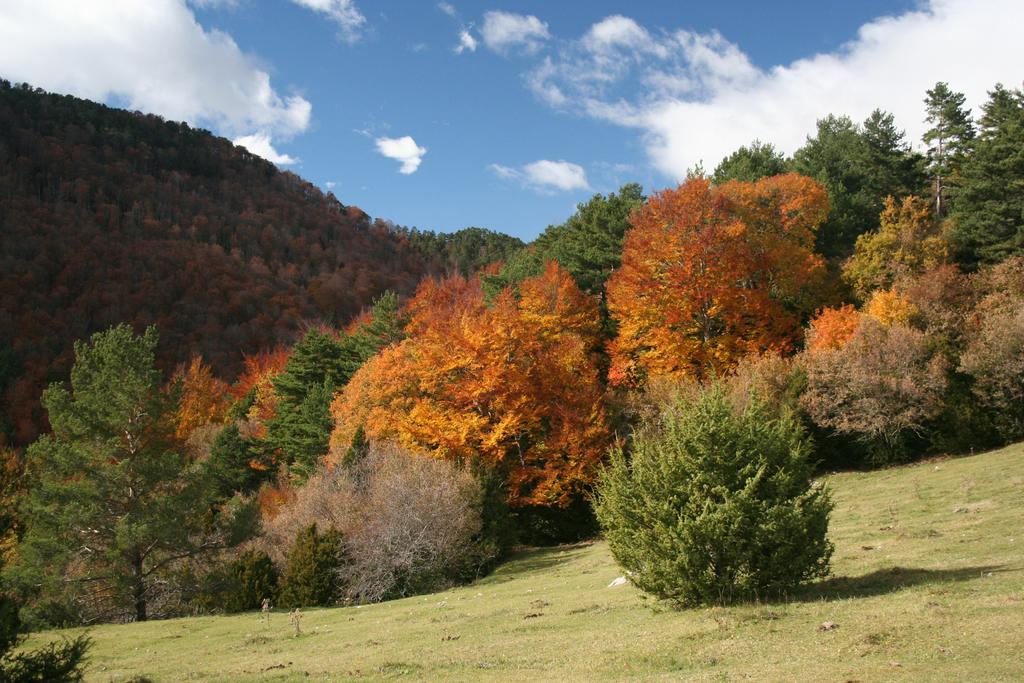What type of vegetation is present in the image? There are many trees and grass visible in the image. Can you describe the plant in the image? There is a plant in the image, but its specific characteristics are not mentioned in the facts. What is located on the left side of the image? There is a mountain on the left side of the image. What is visible at the top of the image? The sky is visible at the top of the image, and clouds are present in the sky. What type of cloth is draped over the mountain in the image? There is no cloth draped over the mountain in the image; it is a natural landscape with trees, grass, and a mountain. How many letters are visible on the trees in the image? There are no letters present on the trees in the image; they are simply trees with no additional features mentioned. 